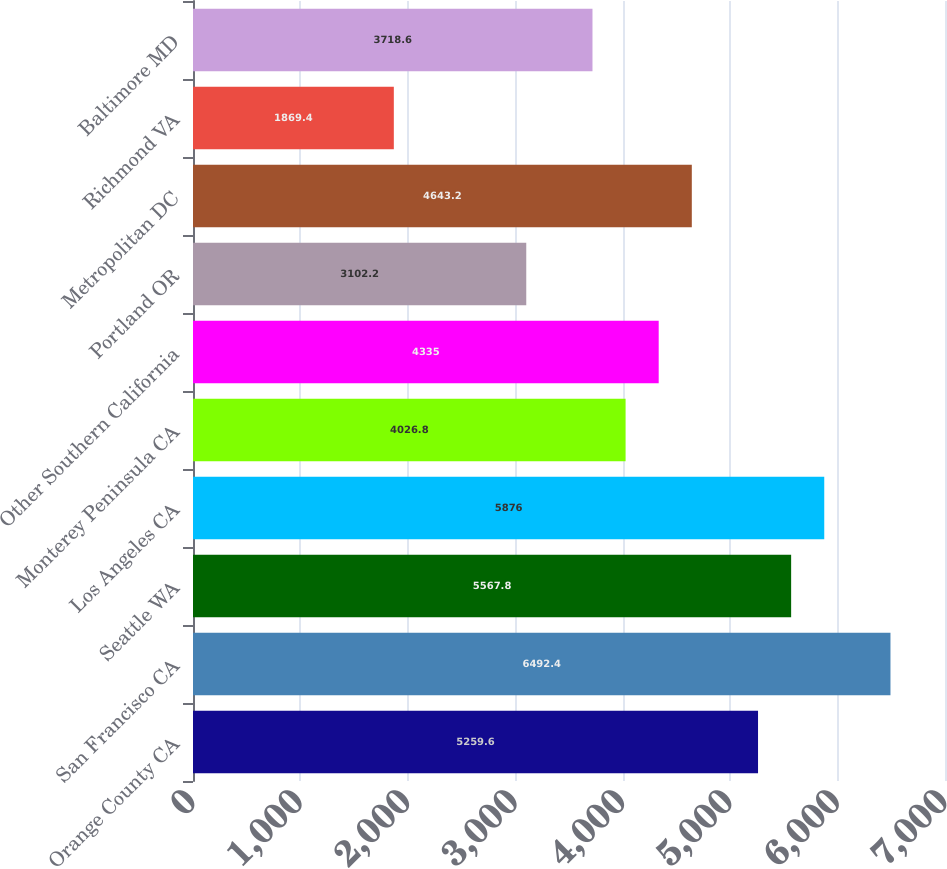<chart> <loc_0><loc_0><loc_500><loc_500><bar_chart><fcel>Orange County CA<fcel>San Francisco CA<fcel>Seattle WA<fcel>Los Angeles CA<fcel>Monterey Peninsula CA<fcel>Other Southern California<fcel>Portland OR<fcel>Metropolitan DC<fcel>Richmond VA<fcel>Baltimore MD<nl><fcel>5259.6<fcel>6492.4<fcel>5567.8<fcel>5876<fcel>4026.8<fcel>4335<fcel>3102.2<fcel>4643.2<fcel>1869.4<fcel>3718.6<nl></chart> 